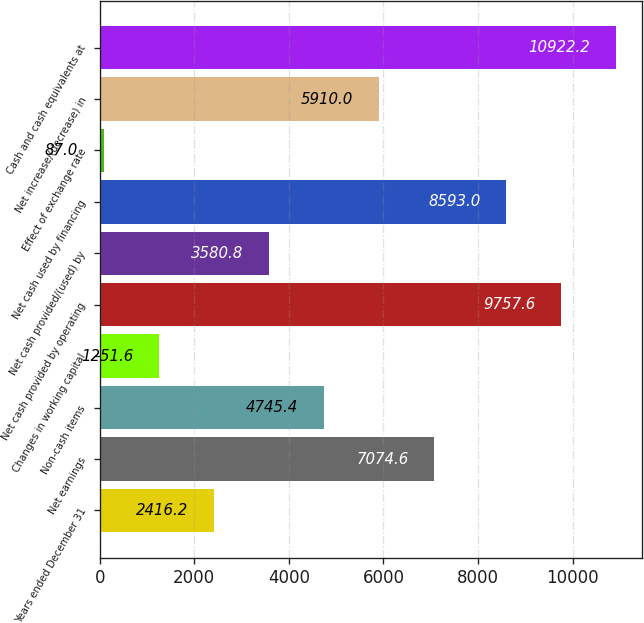Convert chart. <chart><loc_0><loc_0><loc_500><loc_500><bar_chart><fcel>Years ended December 31<fcel>Net earnings<fcel>Non-cash items<fcel>Changes in working capital<fcel>Net cash provided by operating<fcel>Net cash provided/(used) by<fcel>Net cash used by financing<fcel>Effect of exchange rate<fcel>Net increase/(decrease) in<fcel>Cash and cash equivalents at<nl><fcel>2416.2<fcel>7074.6<fcel>4745.4<fcel>1251.6<fcel>9757.6<fcel>3580.8<fcel>8593<fcel>87<fcel>5910<fcel>10922.2<nl></chart> 